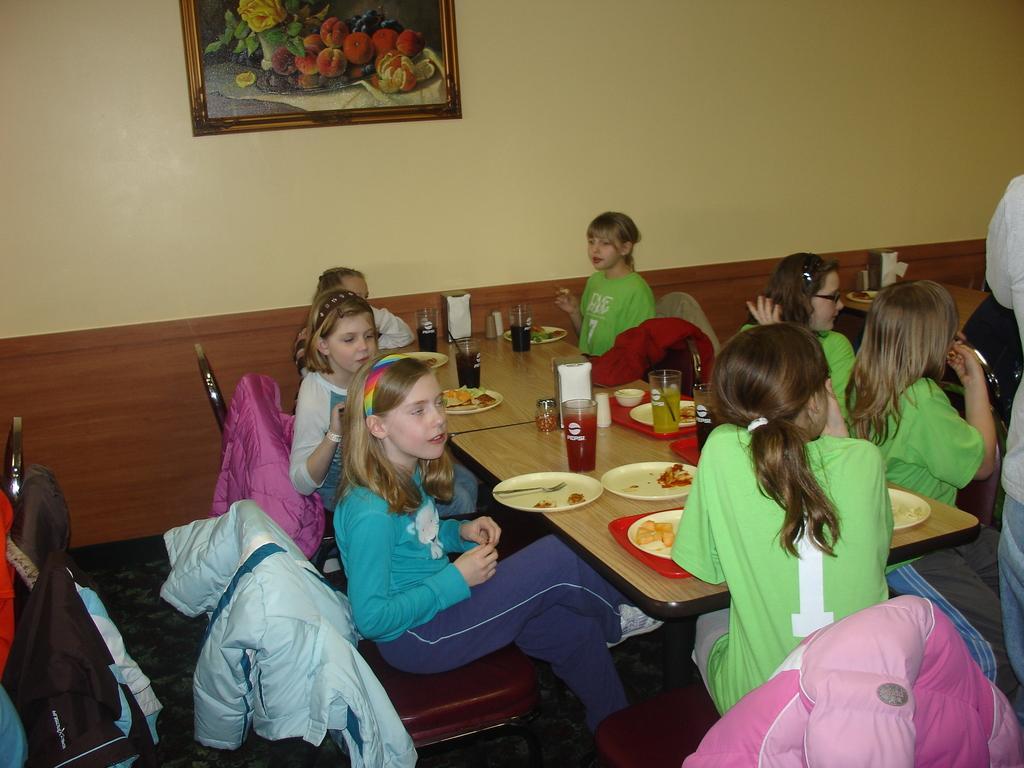In one or two sentences, can you explain what this image depicts? In this image, there are some girls sitting on the chair. There is a table in front of them. This table contains glasses and plates. There is a plate on this plate. There is a photo frame attached to the wall. These girls are wearing clothes. 